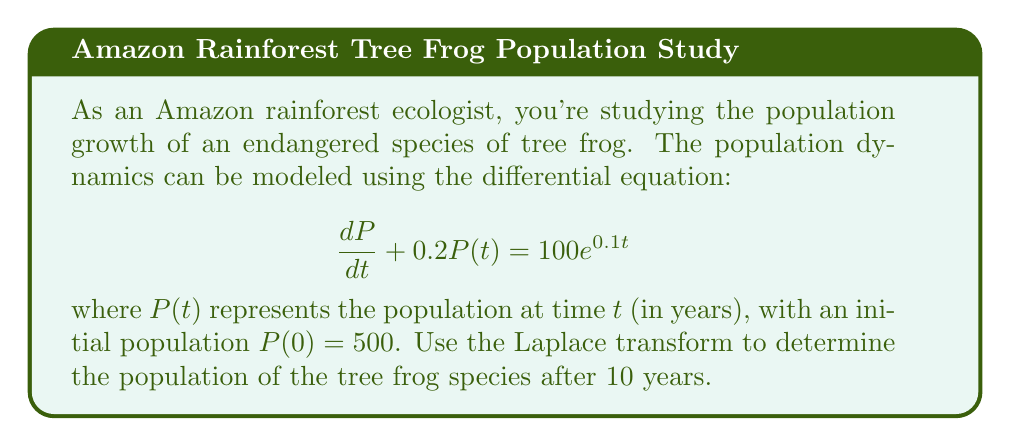Teach me how to tackle this problem. Let's solve this problem step-by-step using the Laplace transform:

1) First, let's take the Laplace transform of both sides of the equation:
   $$\mathcal{L}\{\frac{dP}{dt} + 0.2P(t)\} = \mathcal{L}\{100e^{0.1t}\}$$

2) Using Laplace transform properties:
   $$sP(s) - P(0) + 0.2P(s) = \frac{100}{s-0.1}$$

3) Substitute the initial condition $P(0) = 500$:
   $$sP(s) - 500 + 0.2P(s) = \frac{100}{s-0.1}$$

4) Collect terms with $P(s)$:
   $$(s + 0.2)P(s) = \frac{100}{s-0.1} + 500$$

5) Solve for $P(s)$:
   $$P(s) = \frac{100}{(s+0.2)(s-0.1)} + \frac{500}{s+0.2}$$

6) Use partial fraction decomposition:
   $$P(s) = \frac{A}{s+0.2} + \frac{B}{s-0.1} + \frac{500}{s+0.2}$$
   where $A = -333.33$ and $B = 333.33$

7) Now we can write $P(s)$ as:
   $$P(s) = \frac{166.67}{s+0.2} + \frac{333.33}{s-0.1}$$

8) Take the inverse Laplace transform:
   $$P(t) = 166.67e^{-0.2t} + 333.33e^{0.1t}$$

9) To find the population after 10 years, substitute $t = 10$:
   $$P(10) = 166.67e^{-2} + 333.33e^{1} = 166.67(0.1353) + 333.33(2.7183)$$
   $$P(10) = 22.55 + 906.06 = 928.61$$

Therefore, the population of the tree frog species after 10 years is approximately 929 (rounded to the nearest whole number).
Answer: 929 tree frogs 